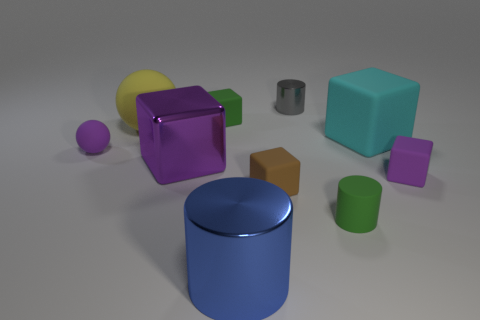Are there more tiny green spheres than large purple cubes?
Your response must be concise. No. What is the size of the rubber sphere that is to the left of the large rubber thing left of the small gray metal thing?
Your response must be concise. Small. There is a large metal object that is the same shape as the tiny brown thing; what color is it?
Provide a short and direct response. Purple. How big is the shiny cube?
Provide a short and direct response. Large. What number of cylinders are either small green objects or blue objects?
Ensure brevity in your answer.  2. The rubber thing that is the same shape as the tiny metallic object is what size?
Ensure brevity in your answer.  Small. What number of small purple balls are there?
Ensure brevity in your answer.  1. Does the yellow matte thing have the same shape as the tiny green thing that is on the left side of the small green rubber cylinder?
Your answer should be compact. No. What size is the shiny thing that is behind the large purple cube?
Your answer should be compact. Small. What is the large purple block made of?
Give a very brief answer. Metal. 